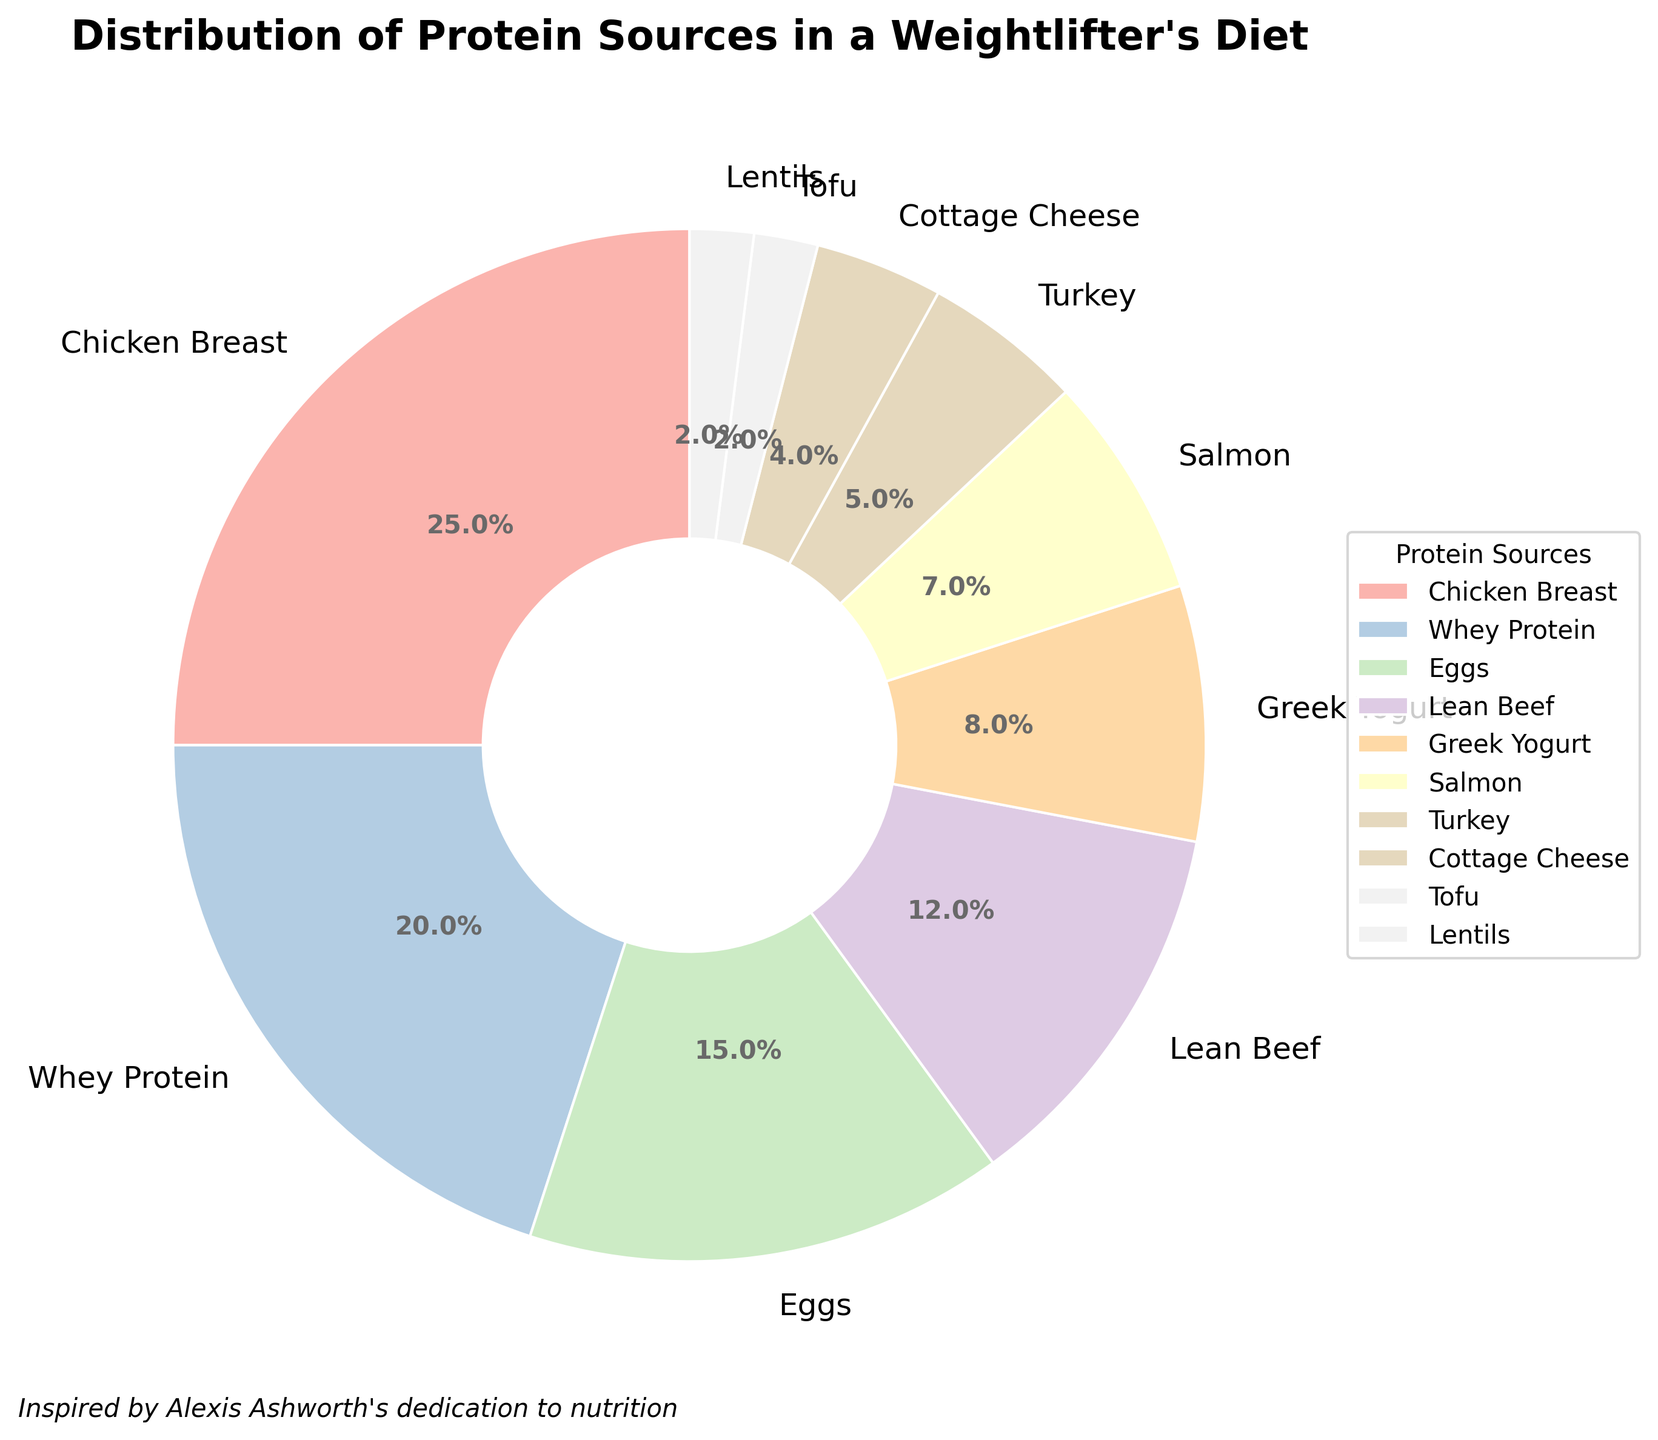What is the most common protein source in the weightlifter's diet? The largest portion of the pie chart corresponds to Chicken Breast at 25%, making it the most common protein source.
Answer: Chicken Breast Which protein source contributes the least to the diet? The smallest wedge in the pie chart is labeled Tofu and Lentils, each contributing 2%.
Answer: Tofu and Lentils How much greater is the percentage of Chicken Breast than Salmon? Chicken Breast accounts for 25% of the diet, while Salmon accounts for 7%. The difference is 25% - 7% = 18%.
Answer: 18% What is the total percentage contribution of Eggs and Greek Yogurt combined? Eggs contribute 15% and Greek Yogurt contributes 8%. Their combined percentage is 15% + 8% = 23%.
Answer: 23% How do the contributions of Whey Protein and Lean Beef compare? Whey Protein contributes 20%, while Lean Beef contributes 12%. Therefore, Whey Protein's contribution is greater by 8%.
Answer: Whey Protein contributes 8% more What percentage of the diet comes from non-meat sources (Whey Protein, Greek Yogurt, Cottage Cheese, Tofu, Lentils)? Calculate the non-meat protein sources: Whey Protein (20%), Greek Yogurt (8%), Cottage Cheese (4%), Tofu (2%), Lentils (2%). The total is 20% + 8% + 4% + 2% + 2% = 36%.
Answer: 36% Is the combined percentage of Turkey and Cottage Cheese greater or less than the contribution of Eggs? Turkey contributes 5% and Cottage Cheese contributes 4%, totaling 5% + 4% = 9%, which is less than the 15% from Eggs.
Answer: Less What portion of the pie chart represents protein sources contributing 5% or less? The pie chart shows Turkey (5%), Cottage Cheese (4%), Tofu (2%), and Lentils (2%), collectively making up 5% + 4% + 2% + 2% = 13%.
Answer: 13% If you combine the percentages of Greek Yogurt, Salmon, and Turkey, what do you get? Greek Yogurt contributes 8%, Salmon contributes 7%, and Turkey contributes 5%. Their combined contribution is 8% + 7% + 5% = 20%.
Answer: 20% Which protein sources combined contribute exactly 30% of the diet? Adding the percentages to find combinations: Eggs (15%) + Lean Beef (12%) + Cottage Cheese (4%) are closest but sum up to 31%; thus, Greek Yogurt (8%) + Chicken Breast (25%) = 8% + 25% = 33%. Correct combination: None precisely combine to 30%.
Answer: None 